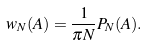<formula> <loc_0><loc_0><loc_500><loc_500>w _ { N } ( A ) = \frac { 1 } { \pi N } P _ { N } ( A ) .</formula> 